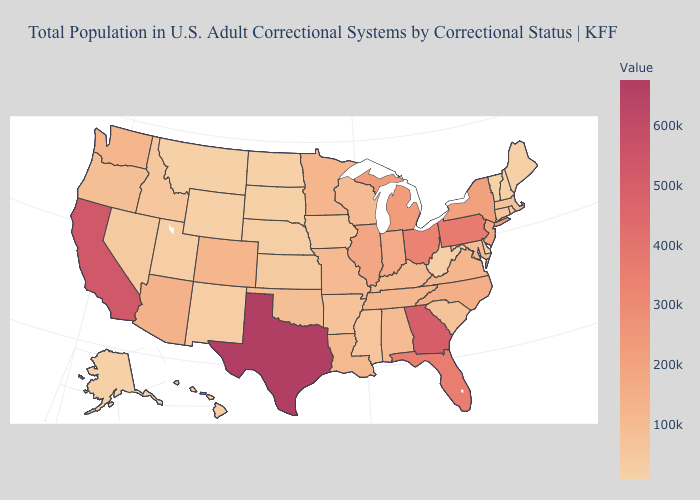Which states have the lowest value in the USA?
Keep it brief. Vermont. Which states have the lowest value in the USA?
Quick response, please. Vermont. Does New York have the highest value in the USA?
Be succinct. No. Which states have the highest value in the USA?
Short answer required. Texas. Does Texas have the highest value in the South?
Quick response, please. Yes. 